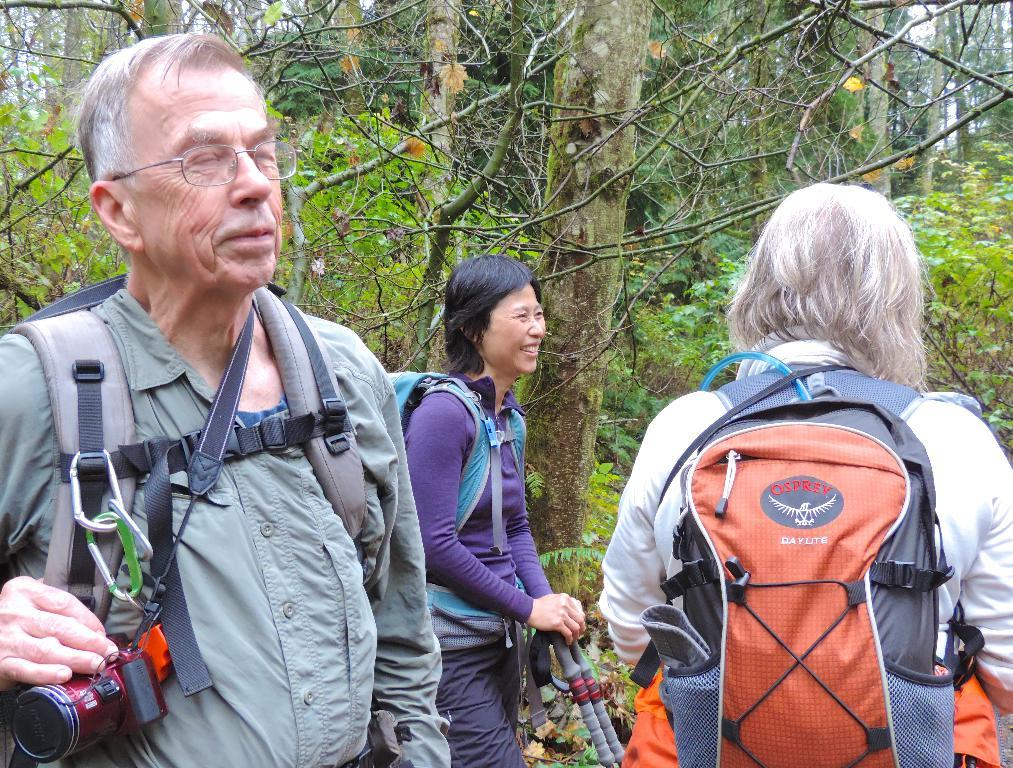How many people are in the image? There are three persons in the image. What are the persons doing in the image? The persons are carrying bags, and one person is holding a camera. Can you describe the expression of one of the persons? A woman is smiling in the image. What can be seen in the background of the image? There are trees visible in the background. What type of potato is being used to create a plot in the image? There is no potato or plot present in the image. What kind of lumber is visible in the image? There is no lumber visible in the image. 